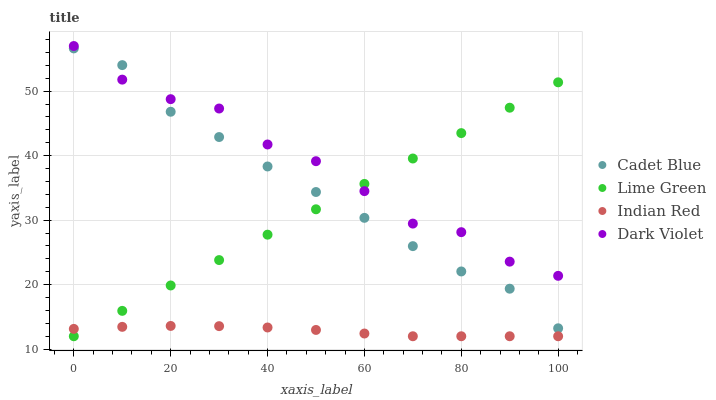Does Indian Red have the minimum area under the curve?
Answer yes or no. Yes. Does Dark Violet have the maximum area under the curve?
Answer yes or no. Yes. Does Lime Green have the minimum area under the curve?
Answer yes or no. No. Does Lime Green have the maximum area under the curve?
Answer yes or no. No. Is Lime Green the smoothest?
Answer yes or no. Yes. Is Dark Violet the roughest?
Answer yes or no. Yes. Is Dark Violet the smoothest?
Answer yes or no. No. Is Lime Green the roughest?
Answer yes or no. No. Does Lime Green have the lowest value?
Answer yes or no. Yes. Does Dark Violet have the lowest value?
Answer yes or no. No. Does Dark Violet have the highest value?
Answer yes or no. Yes. Does Lime Green have the highest value?
Answer yes or no. No. Is Indian Red less than Cadet Blue?
Answer yes or no. Yes. Is Dark Violet greater than Indian Red?
Answer yes or no. Yes. Does Dark Violet intersect Cadet Blue?
Answer yes or no. Yes. Is Dark Violet less than Cadet Blue?
Answer yes or no. No. Is Dark Violet greater than Cadet Blue?
Answer yes or no. No. Does Indian Red intersect Cadet Blue?
Answer yes or no. No. 